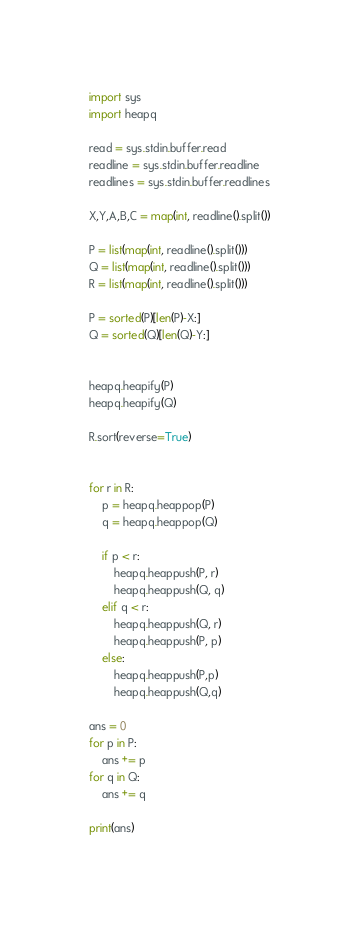Convert code to text. <code><loc_0><loc_0><loc_500><loc_500><_Python_>import sys
import heapq

read = sys.stdin.buffer.read
readline = sys.stdin.buffer.readline
readlines = sys.stdin.buffer.readlines

X,Y,A,B,C = map(int, readline().split())

P = list(map(int, readline().split()))
Q = list(map(int, readline().split()))
R = list(map(int, readline().split()))

P = sorted(P)[len(P)-X:]
Q = sorted(Q)[len(Q)-Y:]


heapq.heapify(P)
heapq.heapify(Q)

R.sort(reverse=True)


for r in R:
    p = heapq.heappop(P)
    q = heapq.heappop(Q)

    if p < r:
        heapq.heappush(P, r)
        heapq.heappush(Q, q)
    elif q < r:
        heapq.heappush(Q, r)
        heapq.heappush(P, p)
    else:
        heapq.heappush(P,p)
        heapq.heappush(Q,q)
        
ans = 0
for p in P:
    ans += p
for q in Q:
    ans += q

print(ans)</code> 